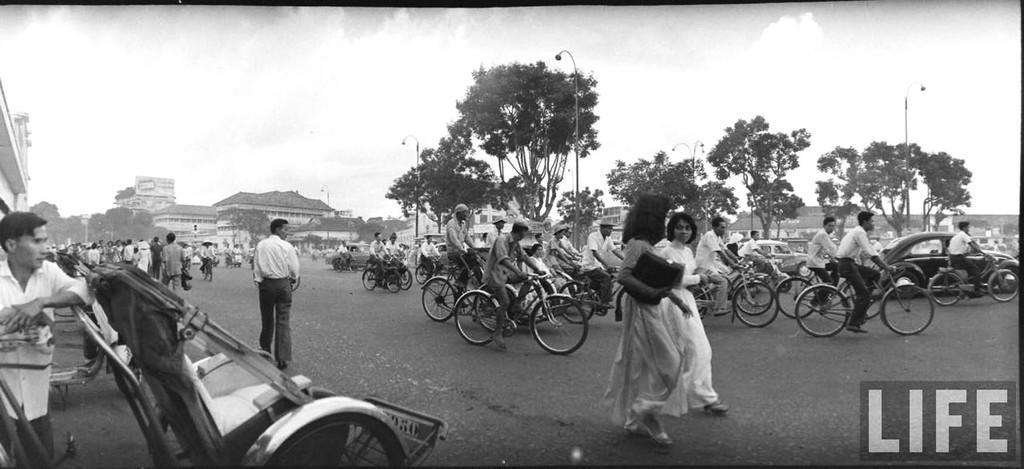How would you summarize this image in a sentence or two? This is the picture on the road. There are group of people riding bicycle on the road, and there two cars and at the left side of the image there are walking on the road. At the back there are buildings and trees. At the top there is a sky and at the left side of the image there is a person and there are street lights beside the road. 